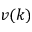Convert formula to latex. <formula><loc_0><loc_0><loc_500><loc_500>v ( k )</formula> 